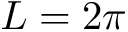<formula> <loc_0><loc_0><loc_500><loc_500>L = 2 \pi</formula> 